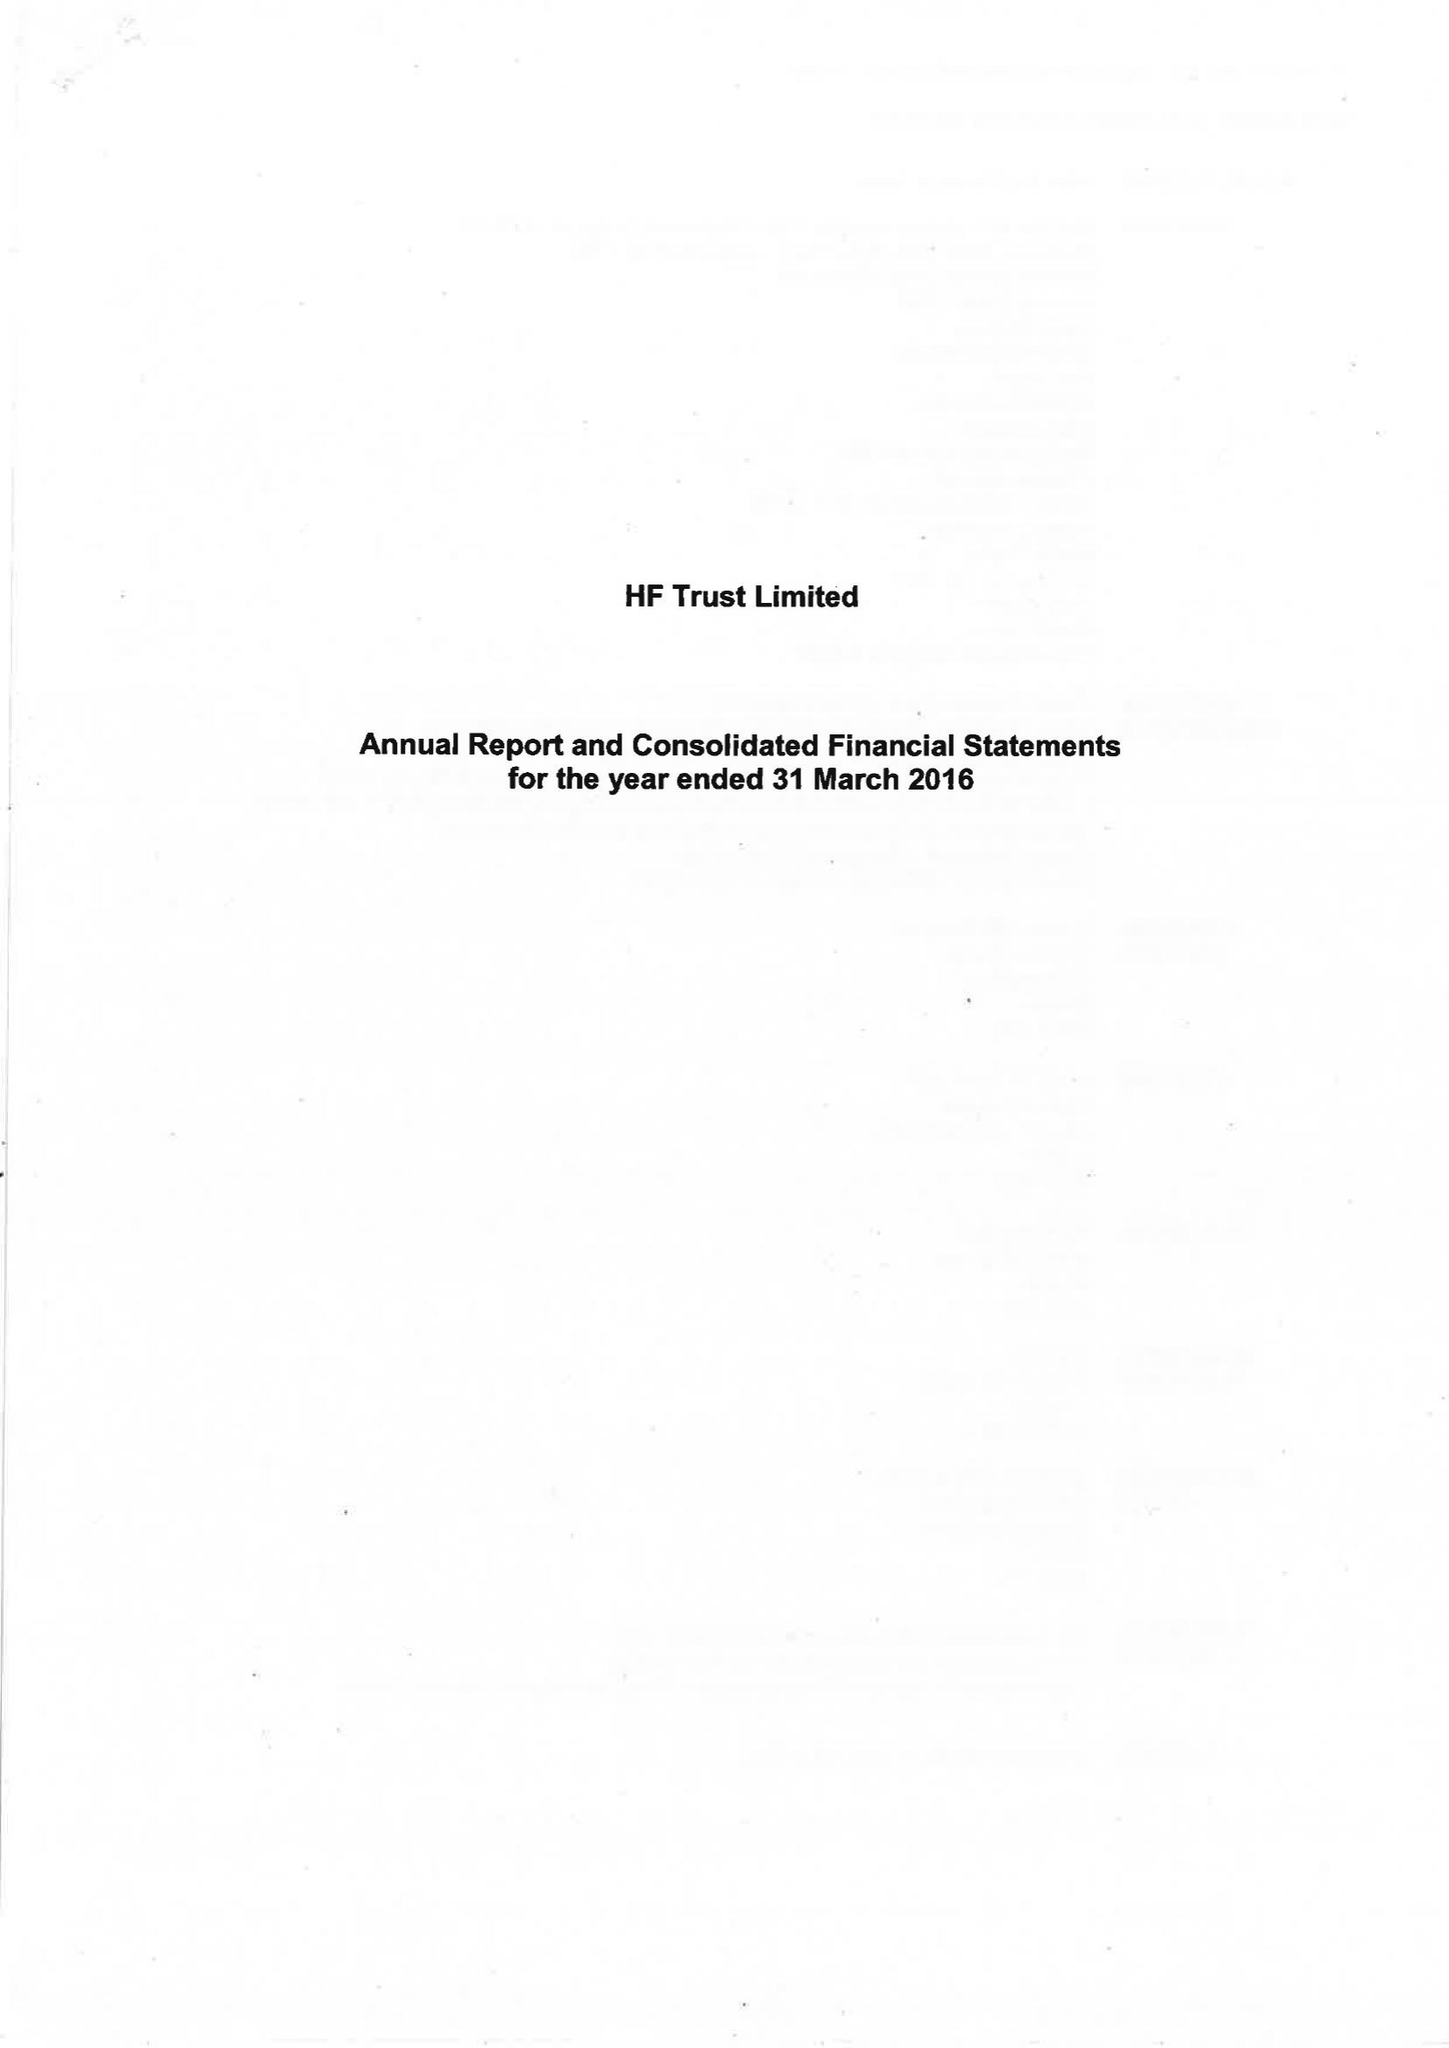What is the value for the address__postcode?
Answer the question using a single word or phrase. BS16 7FL 